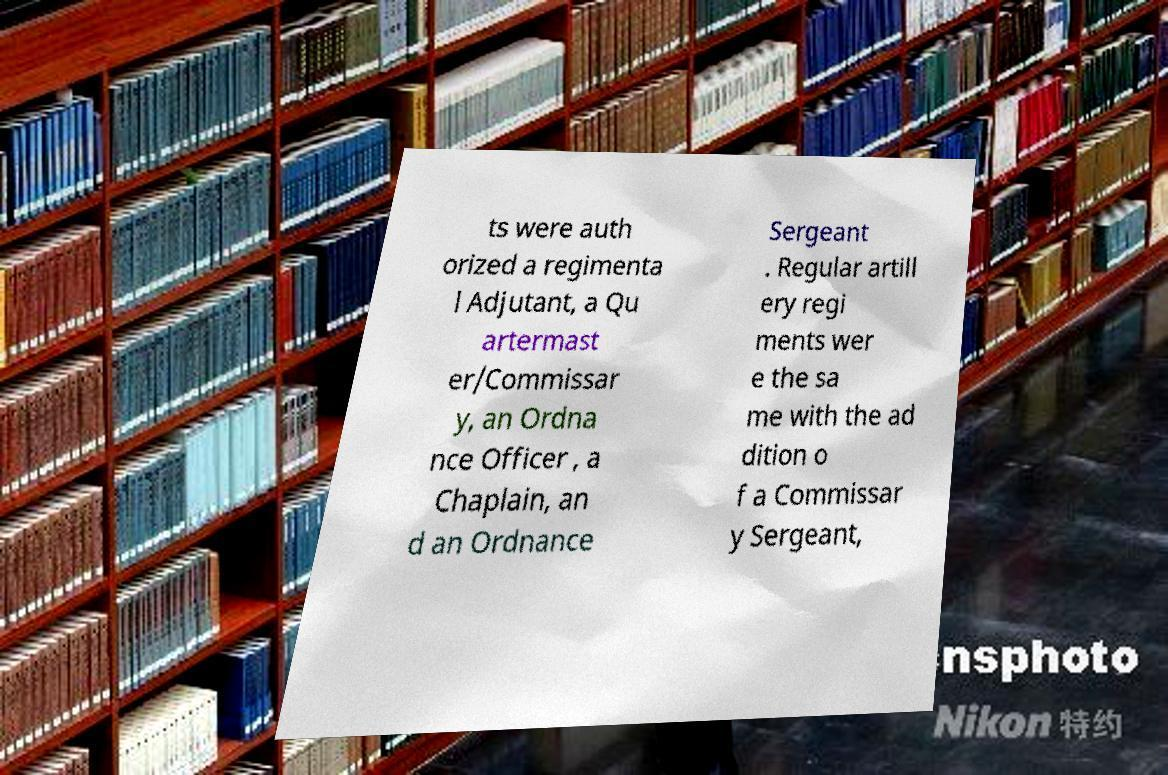What messages or text are displayed in this image? I need them in a readable, typed format. ts were auth orized a regimenta l Adjutant, a Qu artermast er/Commissar y, an Ordna nce Officer , a Chaplain, an d an Ordnance Sergeant . Regular artill ery regi ments wer e the sa me with the ad dition o f a Commissar y Sergeant, 